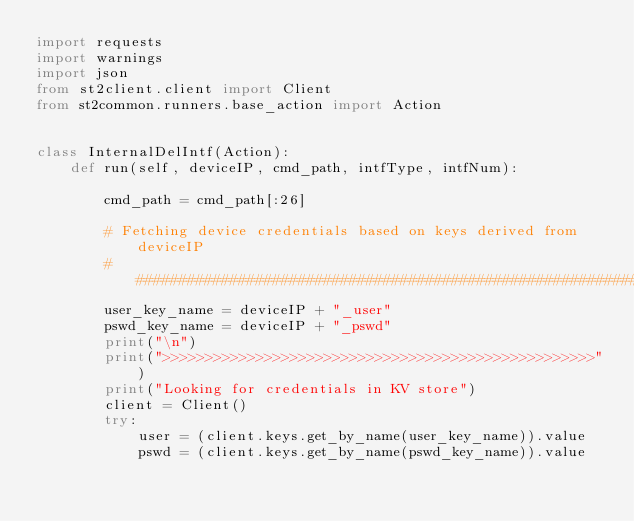<code> <loc_0><loc_0><loc_500><loc_500><_Python_>import requests
import warnings
import json
from st2client.client import Client
from st2common.runners.base_action import Action


class InternalDelIntf(Action):
    def run(self, deviceIP, cmd_path, intfType, intfNum):

        cmd_path = cmd_path[:26]

        # Fetching device credentials based on keys derived from deviceIP
        #################################################################
        user_key_name = deviceIP + "_user"
        pswd_key_name = deviceIP + "_pswd"
        print("\n")
        print(">>>>>>>>>>>>>>>>>>>>>>>>>>>>>>>>>>>>>>>>>>>>>>>>>>>")
        print("Looking for credentials in KV store")
        client = Client()
        try:
            user = (client.keys.get_by_name(user_key_name)).value
            pswd = (client.keys.get_by_name(pswd_key_name)).value</code> 